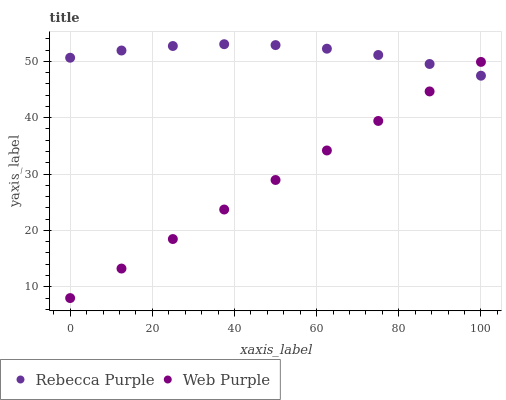Does Web Purple have the minimum area under the curve?
Answer yes or no. Yes. Does Rebecca Purple have the maximum area under the curve?
Answer yes or no. Yes. Does Rebecca Purple have the minimum area under the curve?
Answer yes or no. No. Is Web Purple the smoothest?
Answer yes or no. Yes. Is Rebecca Purple the roughest?
Answer yes or no. Yes. Is Rebecca Purple the smoothest?
Answer yes or no. No. Does Web Purple have the lowest value?
Answer yes or no. Yes. Does Rebecca Purple have the lowest value?
Answer yes or no. No. Does Rebecca Purple have the highest value?
Answer yes or no. Yes. Does Rebecca Purple intersect Web Purple?
Answer yes or no. Yes. Is Rebecca Purple less than Web Purple?
Answer yes or no. No. Is Rebecca Purple greater than Web Purple?
Answer yes or no. No. 